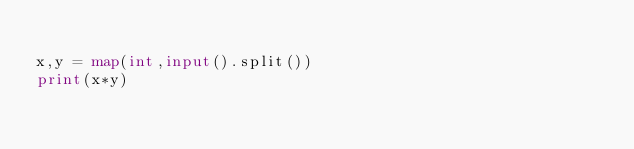<code> <loc_0><loc_0><loc_500><loc_500><_Python_>
x,y = map(int,input().split())
print(x*y)
</code> 